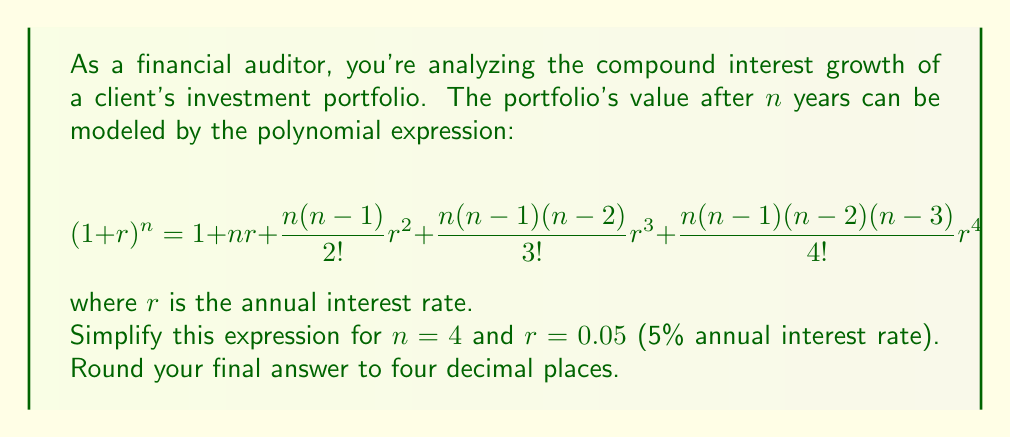Provide a solution to this math problem. Let's approach this step-by-step:

1) First, we substitute $n = 4$ and $r = 0.05$ into the given expression:

   $$(1 + 0.05)^4 = 1 + 4(0.05) + \frac{4(4-1)}{2!}(0.05)^2 + \frac{4(4-1)(4-2)}{3!}(0.05)^3 + \frac{4(4-1)(4-2)(4-3)}{4!}(0.05)^4$$

2) Let's simplify each term:

   - First term: $1$
   - Second term: $4(0.05) = 0.2$
   - Third term: $\frac{4(3)}{2}(0.05)^2 = 6(0.0025) = 0.015$
   - Fourth term: $\frac{4(3)(2)}{6}(0.05)^3 = 4(0.000125) = 0.0005$
   - Fifth term: $\frac{4(3)(2)(1)}{24}(0.05)^4 = 1(0.00000625) = 0.00000625$

3) Now, we add all these terms:

   $$1 + 0.2 + 0.015 + 0.0005 + 0.00000625 = 1.21550625$$

4) Rounding to four decimal places:

   $$1.21550625 \approx 1.2155$$

This result represents the growth factor of the investment after 4 years at a 5% annual compound interest rate.
Answer: 1.2155 